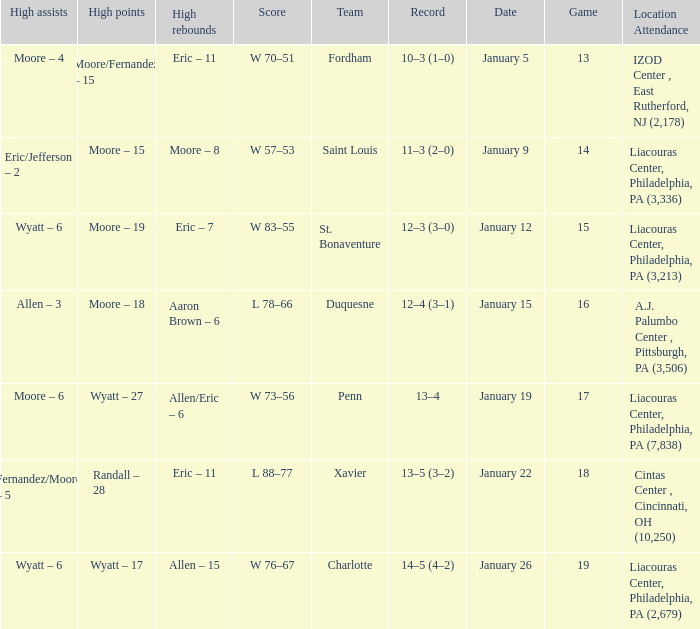Who had the most assists and how many did they have on January 5? Moore – 4. 